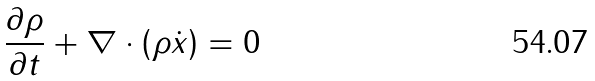Convert formula to latex. <formula><loc_0><loc_0><loc_500><loc_500>\frac { \partial \rho } { \partial t } + \nabla \cdot \left ( \rho \dot { x } \right ) = 0</formula> 